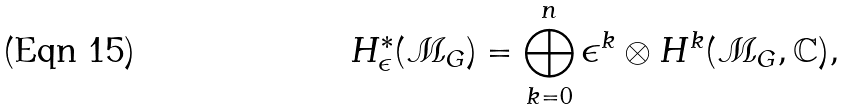Convert formula to latex. <formula><loc_0><loc_0><loc_500><loc_500>H _ { \epsilon } ^ { * } ( \mathcal { M } _ { G } ) = \bigoplus _ { k = 0 } ^ { n } \epsilon ^ { k } \otimes H ^ { k } ( \mathcal { M } _ { G } , { \mathbb { C } } ) ,</formula> 